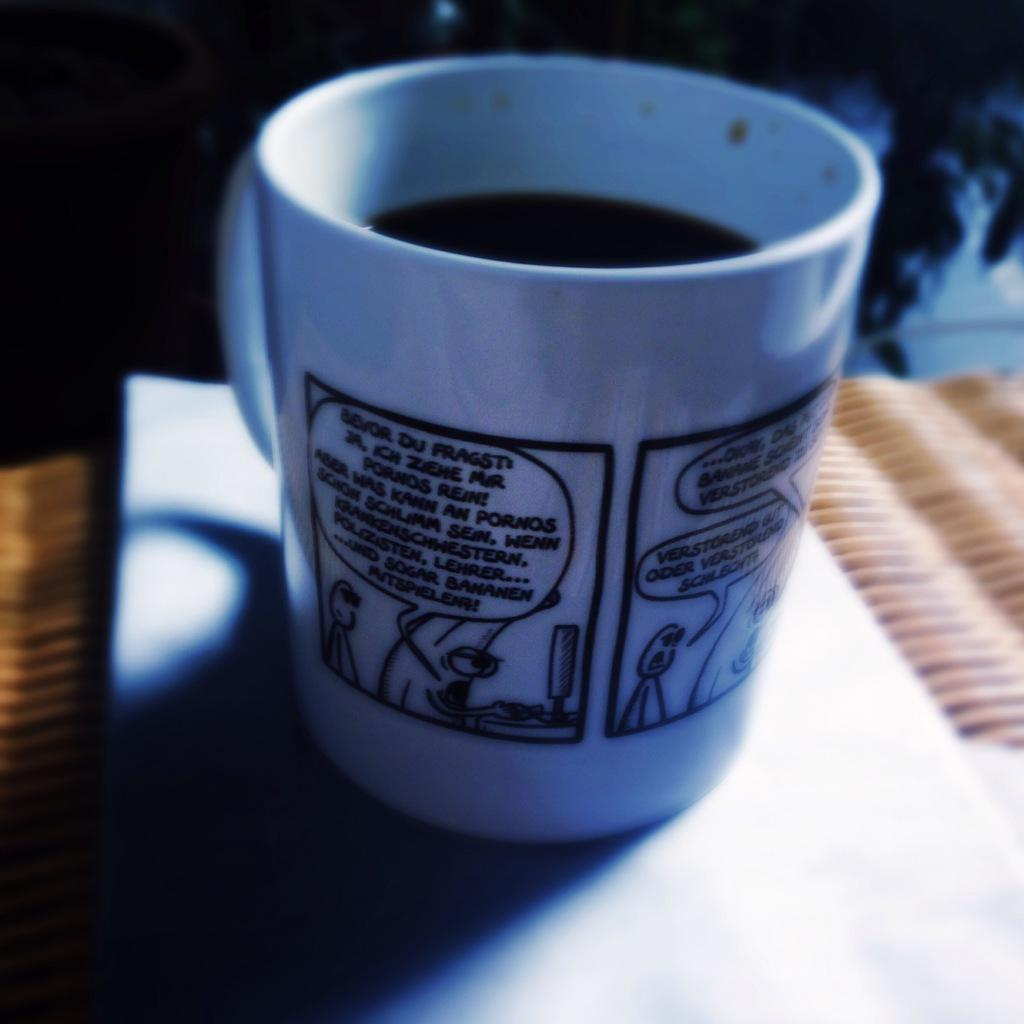What is contained in the cup that is visible in the image? There is a beverage in a cup in the image. Where is the cup located in the image? The cup is placed on a table in the image. Who is the servant attending to in the image? There is no servant present in the image. What mountain range can be seen in the background of the image? There is no mountain range visible in the image; it only features a cup with a beverage on a table. 